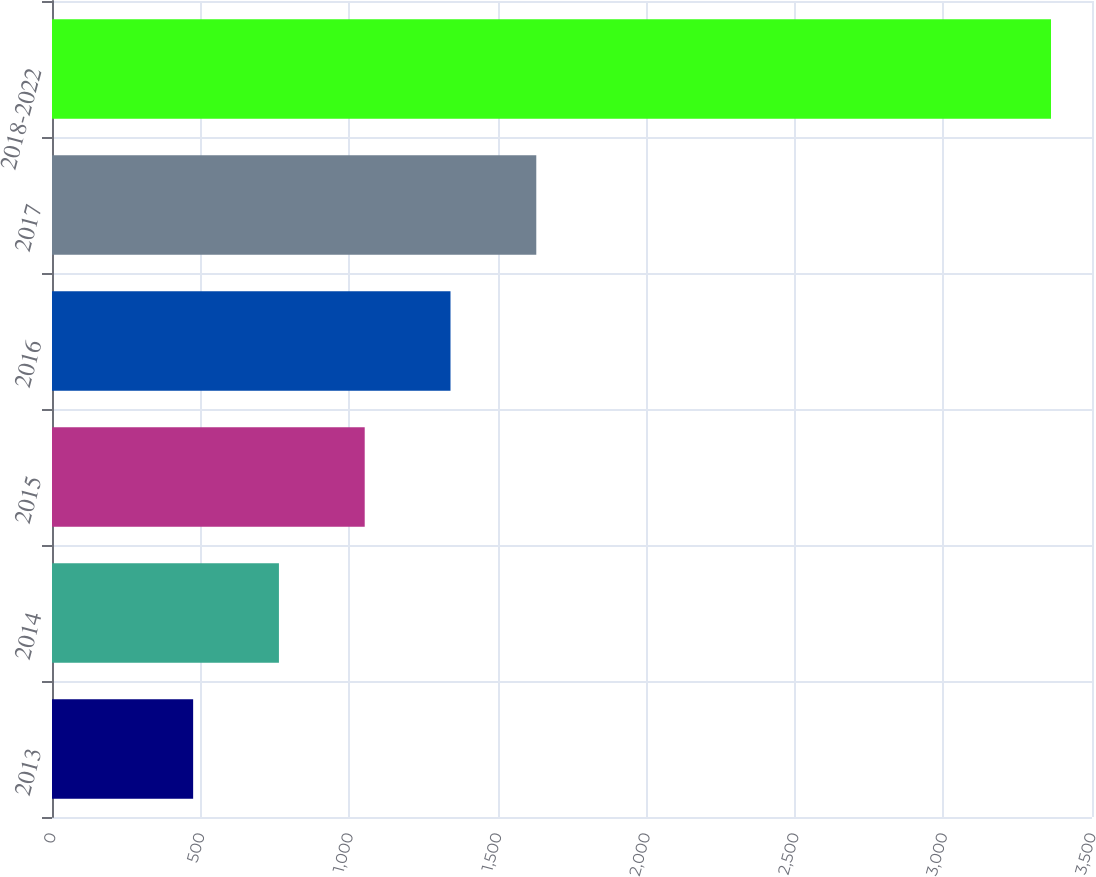Convert chart to OTSL. <chart><loc_0><loc_0><loc_500><loc_500><bar_chart><fcel>2013<fcel>2014<fcel>2015<fcel>2016<fcel>2017<fcel>2018-2022<nl><fcel>475<fcel>763.7<fcel>1052.4<fcel>1341.1<fcel>1629.8<fcel>3362<nl></chart> 